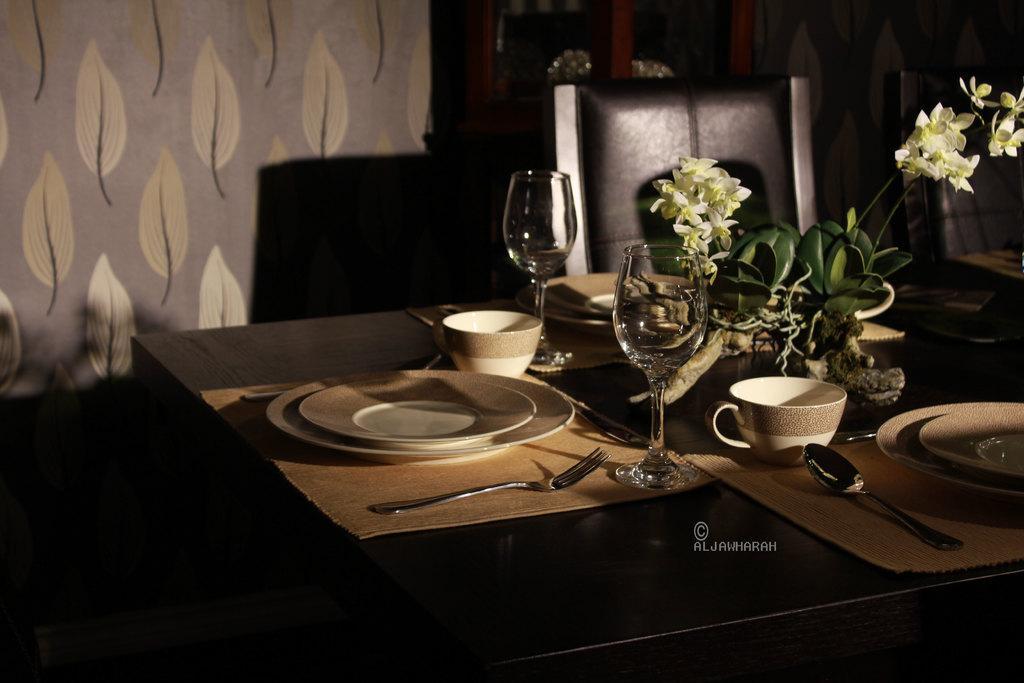Can you describe this image briefly? in this picture we can see the table and one chair in that table we have some plates, cups, and glasses over hear and some flowers on the table at the back side we have some wall in that wall we have some leaf type painting. 